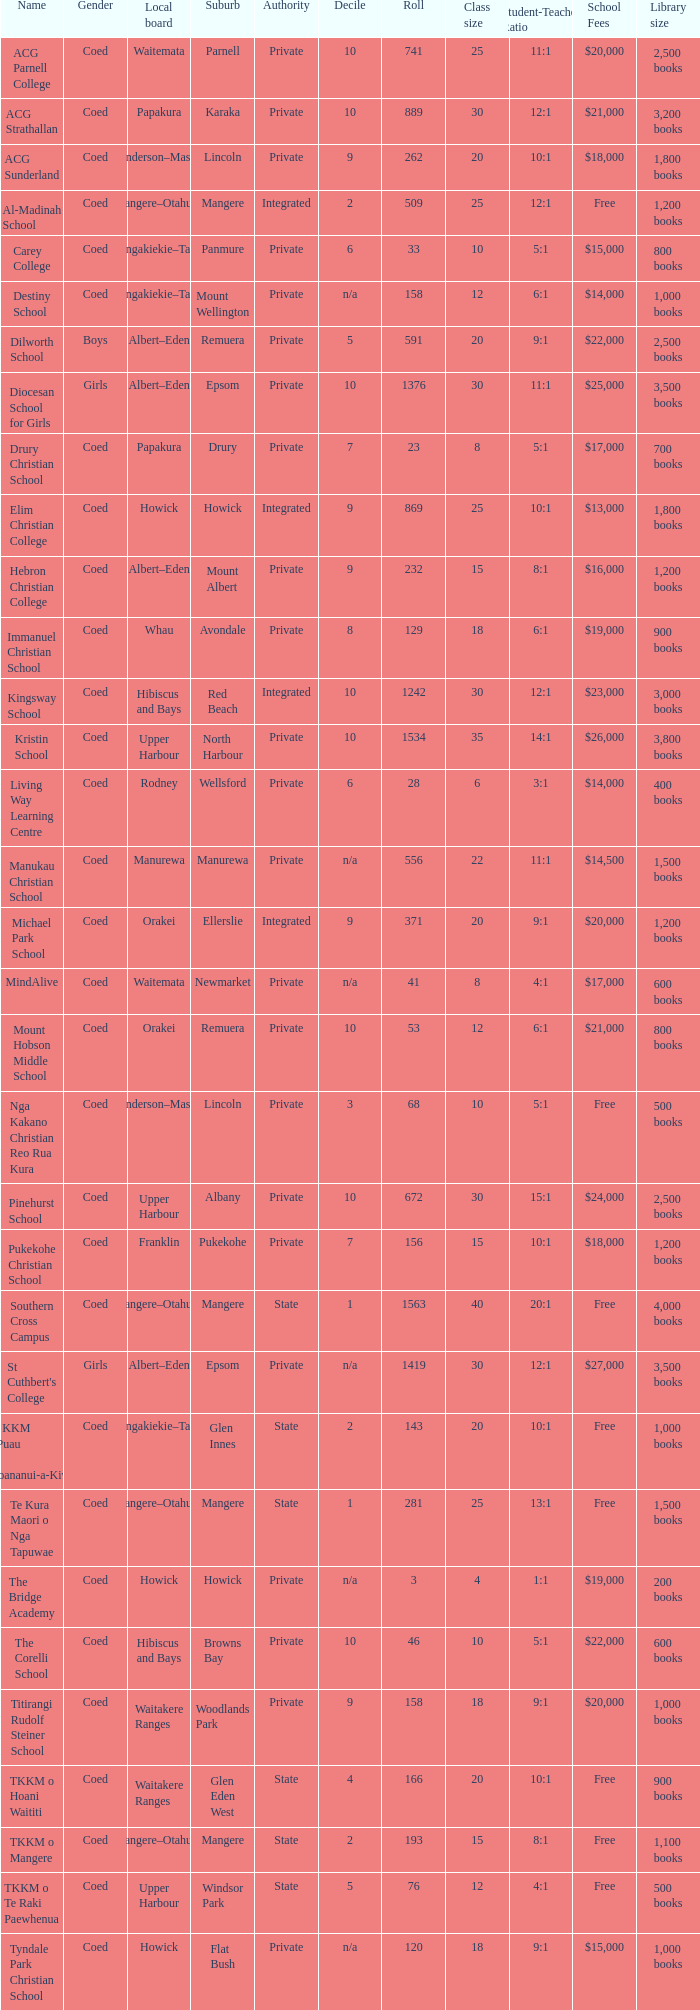What name shows as private authority and hibiscus and bays local board ? The Corelli School. Give me the full table as a dictionary. {'header': ['Name', 'Gender', 'Local board', 'Suburb', 'Authority', 'Decile', 'Roll', 'Class size', 'Student-Teacher Ratio', 'School Fees', 'Library size'], 'rows': [['ACG Parnell College', 'Coed', 'Waitemata', 'Parnell', 'Private', '10', '741', '25', '11:1', '$20,000', '2,500 books'], ['ACG Strathallan', 'Coed', 'Papakura', 'Karaka', 'Private', '10', '889', '30', '12:1', '$21,000', '3,200 books'], ['ACG Sunderland', 'Coed', 'Henderson–Massey', 'Lincoln', 'Private', '9', '262', '20', '10:1', '$18,000', '1,800 books'], ['Al-Madinah School', 'Coed', 'Mangere–Otahuhu', 'Mangere', 'Integrated', '2', '509', '25', '12:1', 'Free', '1,200 books'], ['Carey College', 'Coed', 'Maungakiekie–Tamaki', 'Panmure', 'Private', '6', '33', '10', '5:1', '$15,000', '800 books'], ['Destiny School', 'Coed', 'Maungakiekie–Tamaki', 'Mount Wellington', 'Private', 'n/a', '158', '12', '6:1', '$14,000', '1,000 books'], ['Dilworth School', 'Boys', 'Albert–Eden', 'Remuera', 'Private', '5', '591', '20', '9:1', '$22,000', '2,500 books'], ['Diocesan School for Girls', 'Girls', 'Albert–Eden', 'Epsom', 'Private', '10', '1376', '30', '11:1', '$25,000', '3,500 books'], ['Drury Christian School', 'Coed', 'Papakura', 'Drury', 'Private', '7', '23', '8', '5:1', '$17,000', '700 books'], ['Elim Christian College', 'Coed', 'Howick', 'Howick', 'Integrated', '9', '869', '25', '10:1', '$13,000', '1,800 books'], ['Hebron Christian College', 'Coed', 'Albert–Eden', 'Mount Albert', 'Private', '9', '232', '15', '8:1', '$16,000', '1,200 books'], ['Immanuel Christian School', 'Coed', 'Whau', 'Avondale', 'Private', '8', '129', '18', '6:1', '$19,000', '900 books'], ['Kingsway School', 'Coed', 'Hibiscus and Bays', 'Red Beach', 'Integrated', '10', '1242', '30', '12:1', '$23,000', '3,000 books'], ['Kristin School', 'Coed', 'Upper Harbour', 'North Harbour', 'Private', '10', '1534', '35', '14:1', '$26,000', '3,800 books'], ['Living Way Learning Centre', 'Coed', 'Rodney', 'Wellsford', 'Private', '6', '28', '6', '3:1', '$14,000', '400 books'], ['Manukau Christian School', 'Coed', 'Manurewa', 'Manurewa', 'Private', 'n/a', '556', '22', '11:1', '$14,500', '1,500 books'], ['Michael Park School', 'Coed', 'Orakei', 'Ellerslie', 'Integrated', '9', '371', '20', '9:1', '$20,000', '1,200 books'], ['MindAlive', 'Coed', 'Waitemata', 'Newmarket', 'Private', 'n/a', '41', '8', '4:1', '$17,000', '600 books'], ['Mount Hobson Middle School', 'Coed', 'Orakei', 'Remuera', 'Private', '10', '53', '12', '6:1', '$21,000', '800 books'], ['Nga Kakano Christian Reo Rua Kura', 'Coed', 'Henderson–Massey', 'Lincoln', 'Private', '3', '68', '10', '5:1', 'Free', '500 books'], ['Pinehurst School', 'Coed', 'Upper Harbour', 'Albany', 'Private', '10', '672', '30', '15:1', '$24,000', '2,500 books'], ['Pukekohe Christian School', 'Coed', 'Franklin', 'Pukekohe', 'Private', '7', '156', '15', '10:1', '$18,000', '1,200 books'], ['Southern Cross Campus', 'Coed', 'Mangere–Otahuhu', 'Mangere', 'State', '1', '1563', '40', '20:1', 'Free', '4,000 books'], ["St Cuthbert's College", 'Girls', 'Albert–Eden', 'Epsom', 'Private', 'n/a', '1419', '30', '12:1', '$27,000', '3,500 books'], ['Te KKM o Puau Te Moananui-a-Kiwa', 'Coed', 'Maungakiekie–Tamaki', 'Glen Innes', 'State', '2', '143', '20', '10:1', 'Free', '1,000 books'], ['Te Kura Maori o Nga Tapuwae', 'Coed', 'Mangere–Otahuhu', 'Mangere', 'State', '1', '281', '25', '13:1', 'Free', '1,500 books'], ['The Bridge Academy', 'Coed', 'Howick', 'Howick', 'Private', 'n/a', '3', '4', '1:1', '$19,000', '200 books'], ['The Corelli School', 'Coed', 'Hibiscus and Bays', 'Browns Bay', 'Private', '10', '46', '10', '5:1', '$22,000', '600 books'], ['Titirangi Rudolf Steiner School', 'Coed', 'Waitakere Ranges', 'Woodlands Park', 'Private', '9', '158', '18', '9:1', '$20,000', '1,000 books'], ['TKKM o Hoani Waititi', 'Coed', 'Waitakere Ranges', 'Glen Eden West', 'State', '4', '166', '20', '10:1', 'Free', '900 books'], ['TKKM o Mangere', 'Coed', 'Mangere–Otahuhu', 'Mangere', 'State', '2', '193', '15', '8:1', 'Free', '1,100 books'], ['TKKM o Te Raki Paewhenua', 'Coed', 'Upper Harbour', 'Windsor Park', 'State', '5', '76', '12', '4:1', 'Free', '500 books'], ['Tyndale Park Christian School', 'Coed', 'Howick', 'Flat Bush', 'Private', 'n/a', '120', '18', '9:1', '$15,000', '1,000 books']]} 